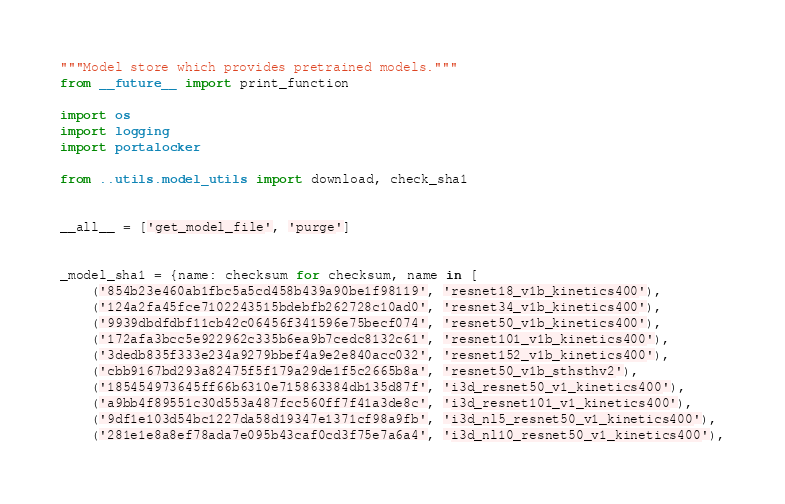<code> <loc_0><loc_0><loc_500><loc_500><_Python_>"""Model store which provides pretrained models."""
from __future__ import print_function

import os
import logging
import portalocker

from ..utils.model_utils import download, check_sha1


__all__ = ['get_model_file', 'purge']


_model_sha1 = {name: checksum for checksum, name in [
    ('854b23e460ab1fbc5a5cd458b439a90be1f98119', 'resnet18_v1b_kinetics400'),
    ('124a2fa45fce7102243515bdebfb262728c10ad0', 'resnet34_v1b_kinetics400'),
    ('9939dbdfdbf11cb42c06456f341596e75becf074', 'resnet50_v1b_kinetics400'),
    ('172afa3bcc5e922962c335b6ea9b7cedc8132c61', 'resnet101_v1b_kinetics400'),
    ('3dedb835f333e234a9279bbef4a9e2e840acc032', 'resnet152_v1b_kinetics400'),
    ('cbb9167bd293a82475f5f179a29de1f5c2665b8a', 'resnet50_v1b_sthsthv2'),
    ('185454973645ff66b6310e715863384db135d87f', 'i3d_resnet50_v1_kinetics400'),
    ('a9bb4f89551c30d553a487fcc560ff7f41a3de8c', 'i3d_resnet101_v1_kinetics400'),
    ('9df1e103d54bc1227da58d19347e1371cf98a9fb', 'i3d_nl5_resnet50_v1_kinetics400'),
    ('281e1e8a8ef78ada7e095b43caf0cd3f75e7a6a4', 'i3d_nl10_resnet50_v1_kinetics400'),</code> 